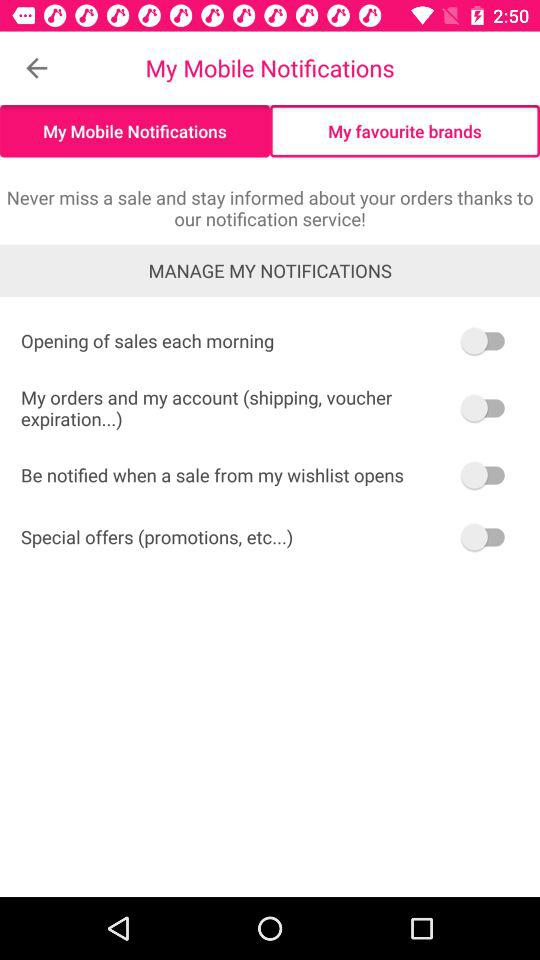What is the status of "Special offers"? The status is "off". 